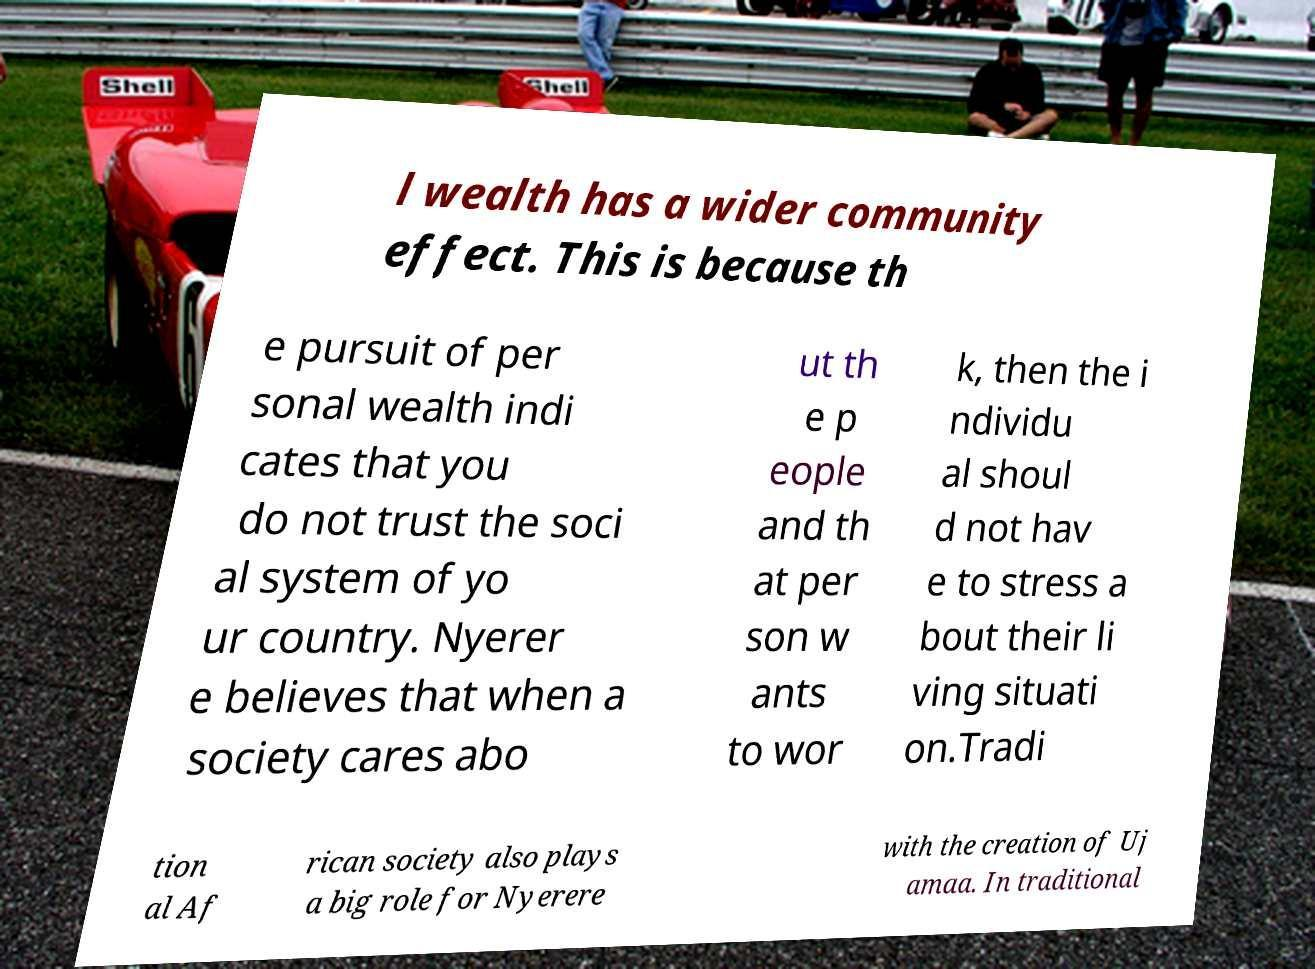I need the written content from this picture converted into text. Can you do that? l wealth has a wider community effect. This is because th e pursuit of per sonal wealth indi cates that you do not trust the soci al system of yo ur country. Nyerer e believes that when a society cares abo ut th e p eople and th at per son w ants to wor k, then the i ndividu al shoul d not hav e to stress a bout their li ving situati on.Tradi tion al Af rican society also plays a big role for Nyerere with the creation of Uj amaa. In traditional 